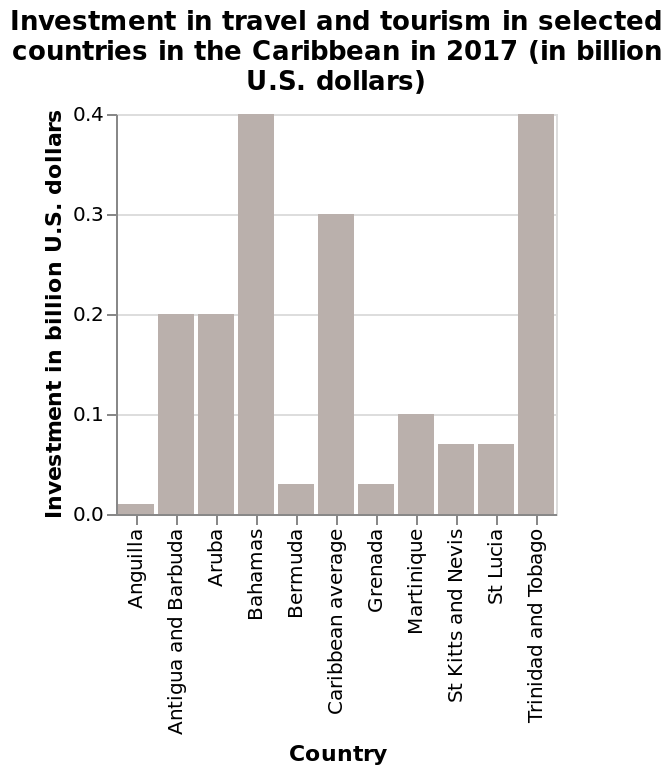<image>
Did Trinidad and Tobago and Antigua & Barbuda invest more or less in tourism than the other Caribbean countries? They invested more. How much did Trinidad and Tobago and Antigua & Barbuda invest in tourism compared to the average of the other Caribbean countries? They invested slightly less than 4 times the average of the others. please enumerates aspects of the construction of the chart Here a is a bar chart named Investment in travel and tourism in selected countries in the Caribbean in 2017 (in billion U.S. dollars). The x-axis measures Country as categorical scale with Anguilla on one end and Trinidad and Tobago at the other while the y-axis shows Investment in billion U.S. dollars along linear scale with a minimum of 0.0 and a maximum of 0.4. How does the investment of Trinidad and Tobago and Antigua & Barbuda compare to the rest of the Caribbean countries in terms of tourism? Their investment in tourism was significantly higher than the rest of the Caribbean countries, but slightly less than 4 times their average investment. Did they invest slightly more than 4 times the average of the others? No.They invested slightly less than 4 times the average of the others. Was their investment in tourism significantly lower than the rest of the Caribbean countries, but slightly more than 4 times their average investment? No.Their investment in tourism was significantly higher than the rest of the Caribbean countries, but slightly less than 4 times their average investment. 